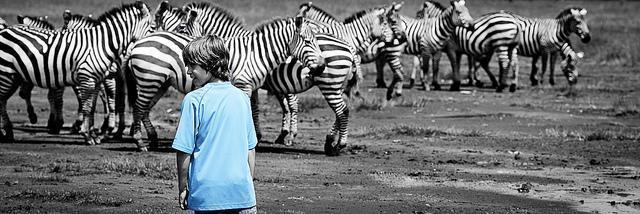How many zebras can be seen?
Give a very brief answer. 6. 